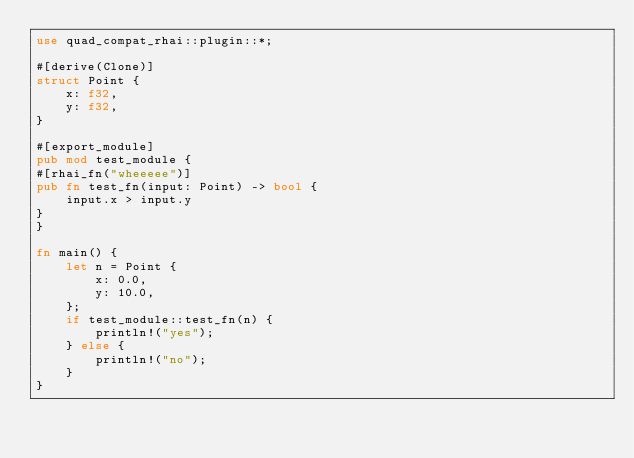Convert code to text. <code><loc_0><loc_0><loc_500><loc_500><_Rust_>use quad_compat_rhai::plugin::*;

#[derive(Clone)]
struct Point {
    x: f32,
    y: f32,
}

#[export_module]
pub mod test_module {
#[rhai_fn("wheeeee")]
pub fn test_fn(input: Point) -> bool {
    input.x > input.y
}
}

fn main() {
    let n = Point {
        x: 0.0,
        y: 10.0,
    };
    if test_module::test_fn(n) {
        println!("yes");
    } else {
        println!("no");
    }
}
</code> 